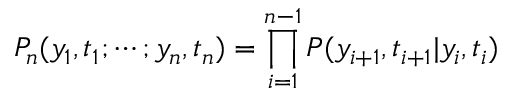Convert formula to latex. <formula><loc_0><loc_0><loc_500><loc_500>P _ { n } ( y _ { 1 } , t _ { 1 } ; \cdots ; y _ { n } , t _ { n } ) = \prod _ { i = 1 } ^ { n - 1 } P ( y _ { i + 1 } , t _ { i + 1 } | y _ { i } , t _ { i } )</formula> 